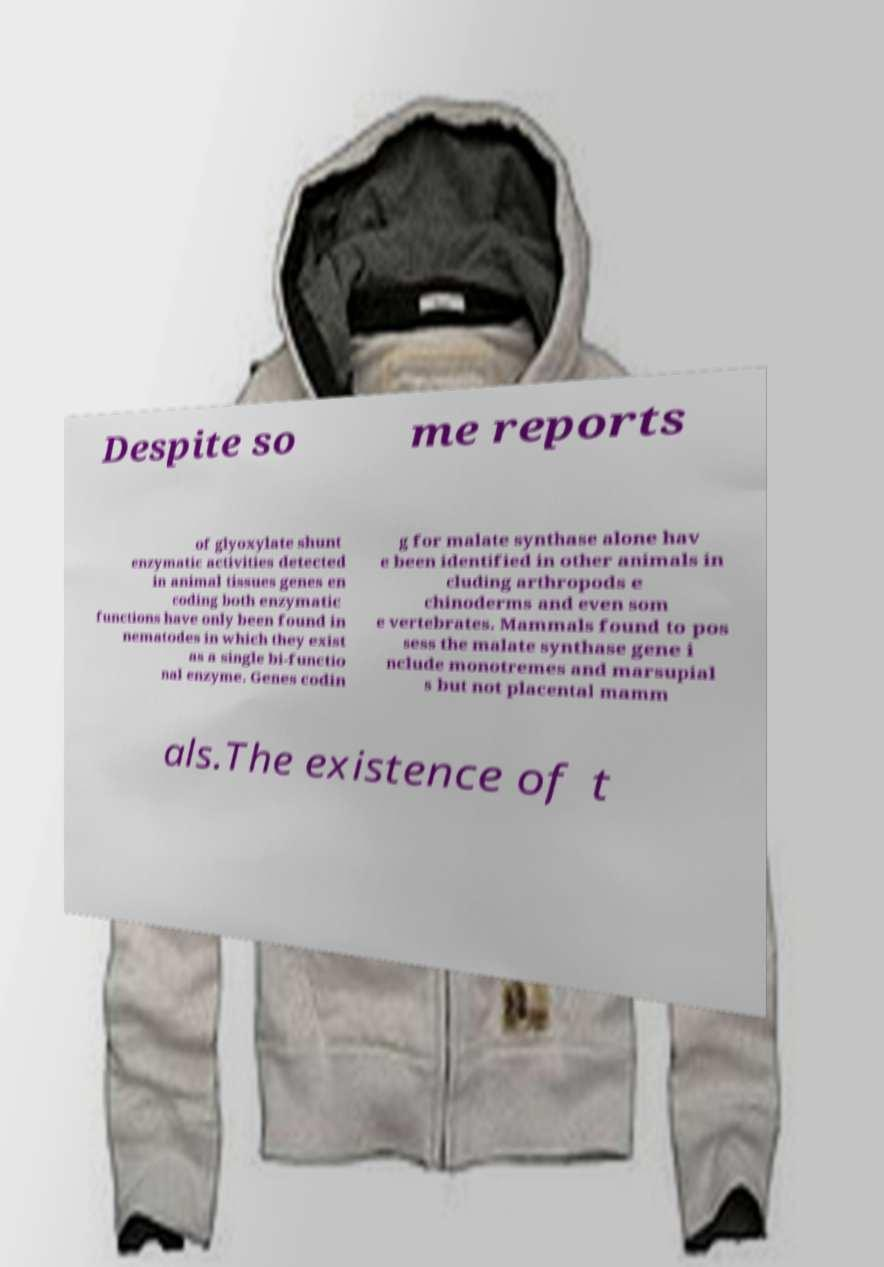There's text embedded in this image that I need extracted. Can you transcribe it verbatim? Despite so me reports of glyoxylate shunt enzymatic activities detected in animal tissues genes en coding both enzymatic functions have only been found in nematodes in which they exist as a single bi-functio nal enzyme. Genes codin g for malate synthase alone hav e been identified in other animals in cluding arthropods e chinoderms and even som e vertebrates. Mammals found to pos sess the malate synthase gene i nclude monotremes and marsupial s but not placental mamm als.The existence of t 